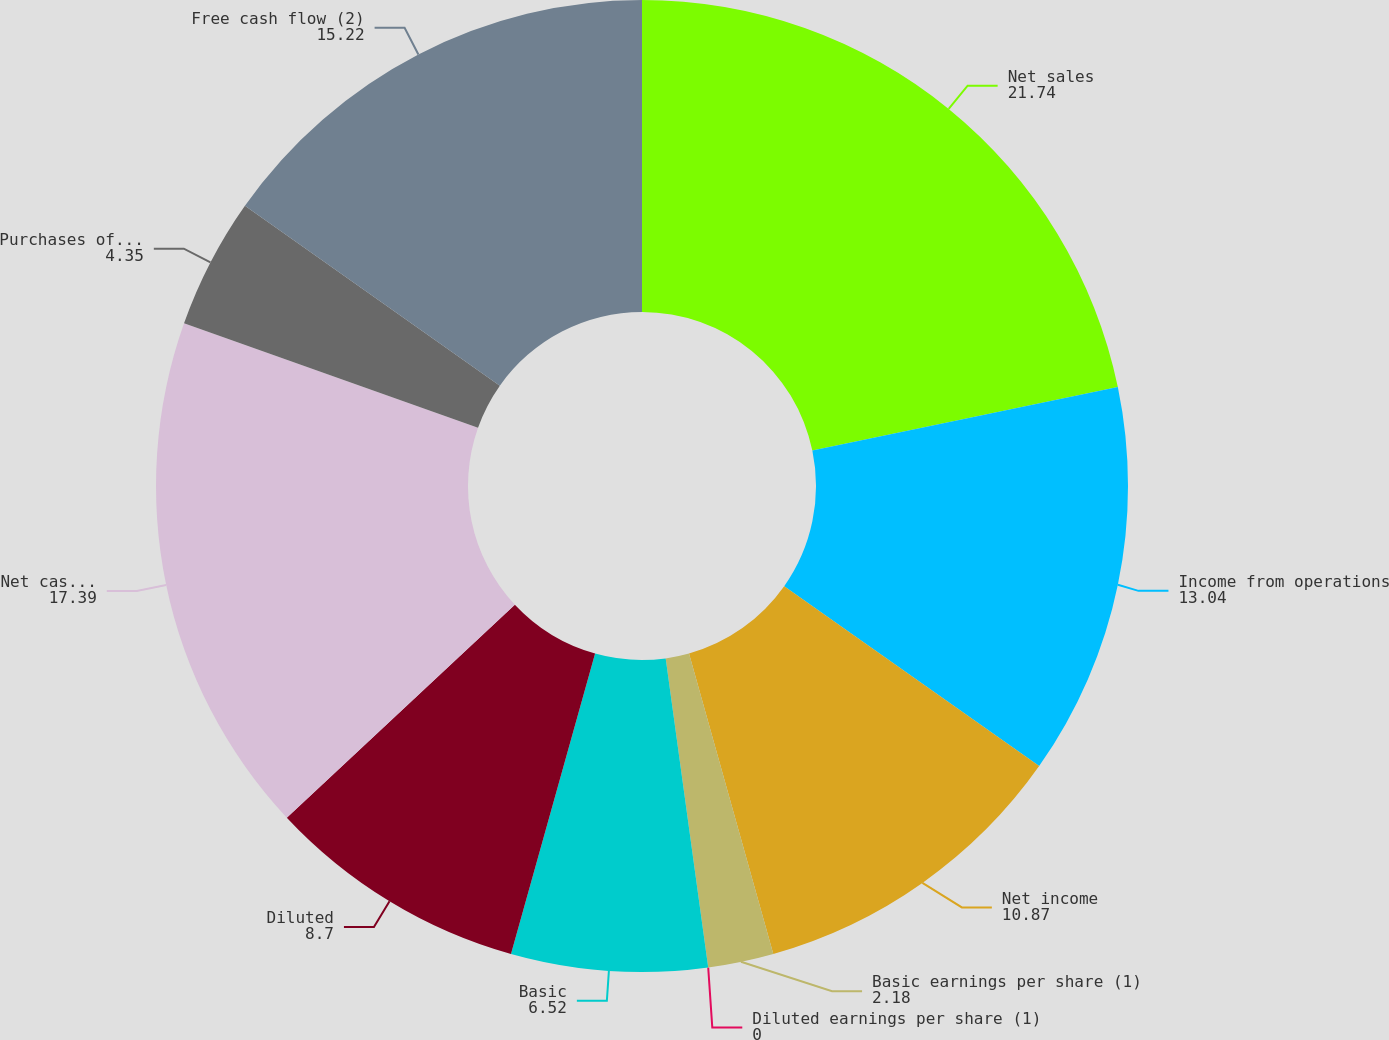Convert chart to OTSL. <chart><loc_0><loc_0><loc_500><loc_500><pie_chart><fcel>Net sales<fcel>Income from operations<fcel>Net income<fcel>Basic earnings per share (1)<fcel>Diluted earnings per share (1)<fcel>Basic<fcel>Diluted<fcel>Net cash provided by operating<fcel>Purchases of fixed assets<fcel>Free cash flow (2)<nl><fcel>21.74%<fcel>13.04%<fcel>10.87%<fcel>2.18%<fcel>0.0%<fcel>6.52%<fcel>8.7%<fcel>17.39%<fcel>4.35%<fcel>15.22%<nl></chart> 